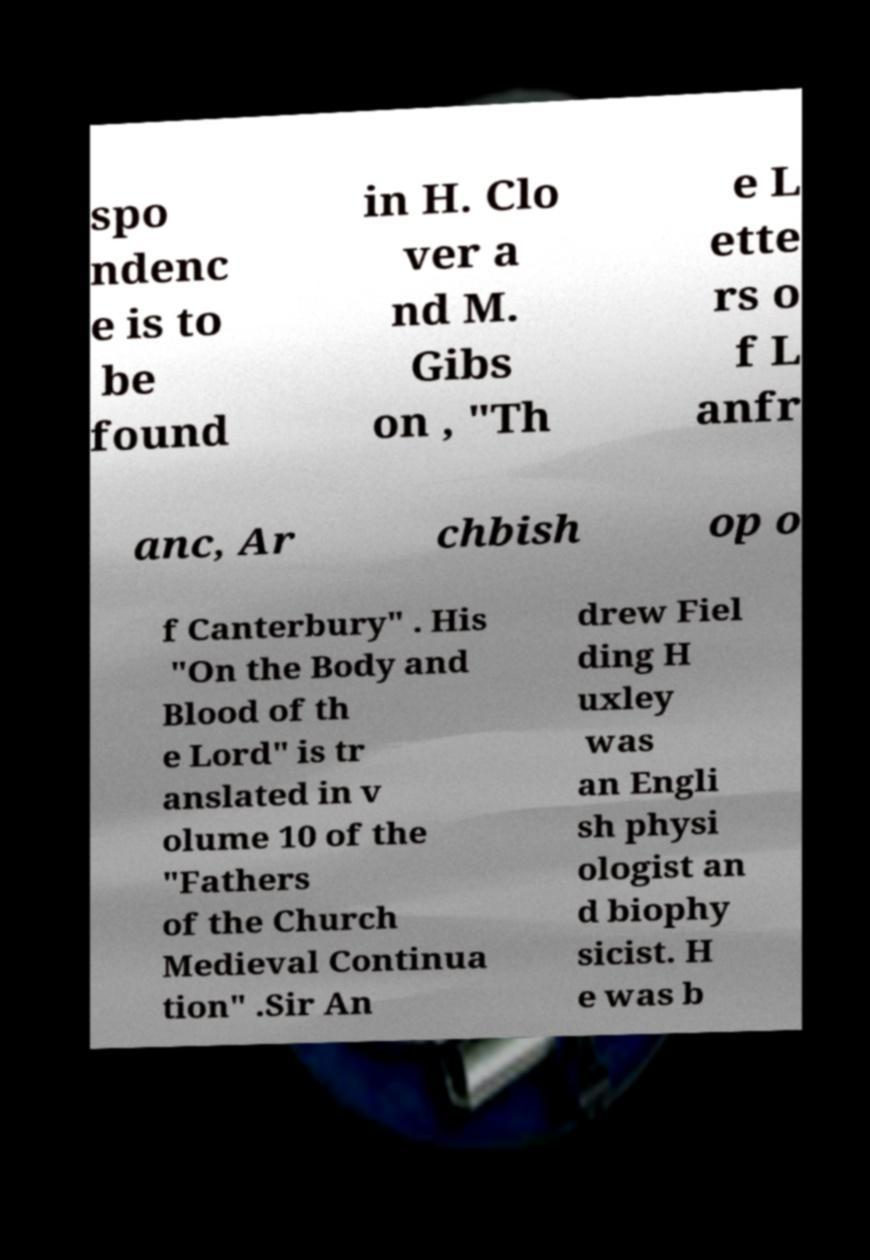Can you read and provide the text displayed in the image?This photo seems to have some interesting text. Can you extract and type it out for me? spo ndenc e is to be found in H. Clo ver a nd M. Gibs on , "Th e L ette rs o f L anfr anc, Ar chbish op o f Canterbury" . His "On the Body and Blood of th e Lord" is tr anslated in v olume 10 of the "Fathers of the Church Medieval Continua tion" .Sir An drew Fiel ding H uxley was an Engli sh physi ologist an d biophy sicist. H e was b 